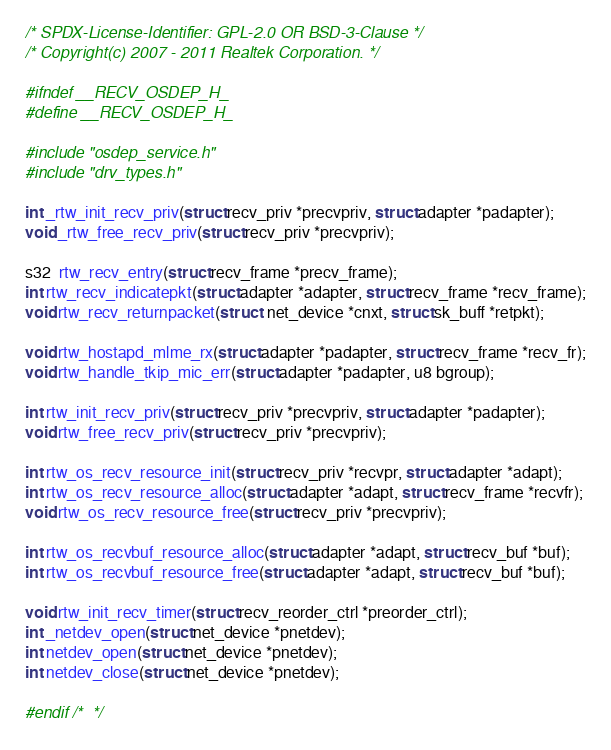<code> <loc_0><loc_0><loc_500><loc_500><_C_>/* SPDX-License-Identifier: GPL-2.0 OR BSD-3-Clause */
/* Copyright(c) 2007 - 2011 Realtek Corporation. */

#ifndef __RECV_OSDEP_H_
#define __RECV_OSDEP_H_

#include "osdep_service.h"
#include "drv_types.h"

int _rtw_init_recv_priv(struct recv_priv *precvpriv, struct adapter *padapter);
void _rtw_free_recv_priv(struct recv_priv *precvpriv);

s32  rtw_recv_entry(struct recv_frame *precv_frame);
int rtw_recv_indicatepkt(struct adapter *adapter, struct recv_frame *recv_frame);
void rtw_recv_returnpacket(struct  net_device *cnxt, struct sk_buff *retpkt);

void rtw_hostapd_mlme_rx(struct adapter *padapter, struct recv_frame *recv_fr);
void rtw_handle_tkip_mic_err(struct adapter *padapter, u8 bgroup);

int rtw_init_recv_priv(struct recv_priv *precvpriv, struct adapter *padapter);
void rtw_free_recv_priv(struct recv_priv *precvpriv);

int rtw_os_recv_resource_init(struct recv_priv *recvpr, struct adapter *adapt);
int rtw_os_recv_resource_alloc(struct adapter *adapt, struct recv_frame *recvfr);
void rtw_os_recv_resource_free(struct recv_priv *precvpriv);

int rtw_os_recvbuf_resource_alloc(struct adapter *adapt, struct recv_buf *buf);
int rtw_os_recvbuf_resource_free(struct adapter *adapt, struct recv_buf *buf);

void rtw_init_recv_timer(struct recv_reorder_ctrl *preorder_ctrl);
int _netdev_open(struct net_device *pnetdev);
int netdev_open(struct net_device *pnetdev);
int netdev_close(struct net_device *pnetdev);

#endif /*  */
</code> 